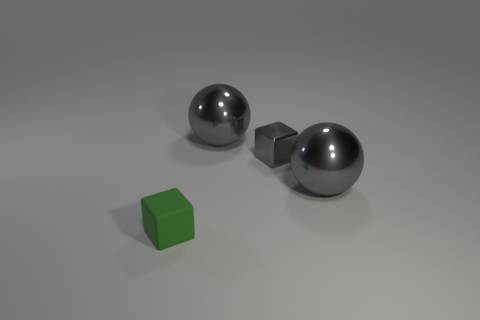Subtract 1 blocks. How many blocks are left? 1 Add 2 big purple cylinders. How many objects exist? 6 Subtract all large gray matte objects. Subtract all small green rubber things. How many objects are left? 3 Add 1 shiny objects. How many shiny objects are left? 4 Add 3 small matte blocks. How many small matte blocks exist? 4 Subtract all green blocks. How many blocks are left? 1 Subtract 0 blue balls. How many objects are left? 4 Subtract all gray blocks. Subtract all red cylinders. How many blocks are left? 1 Subtract all cyan cubes. How many red spheres are left? 0 